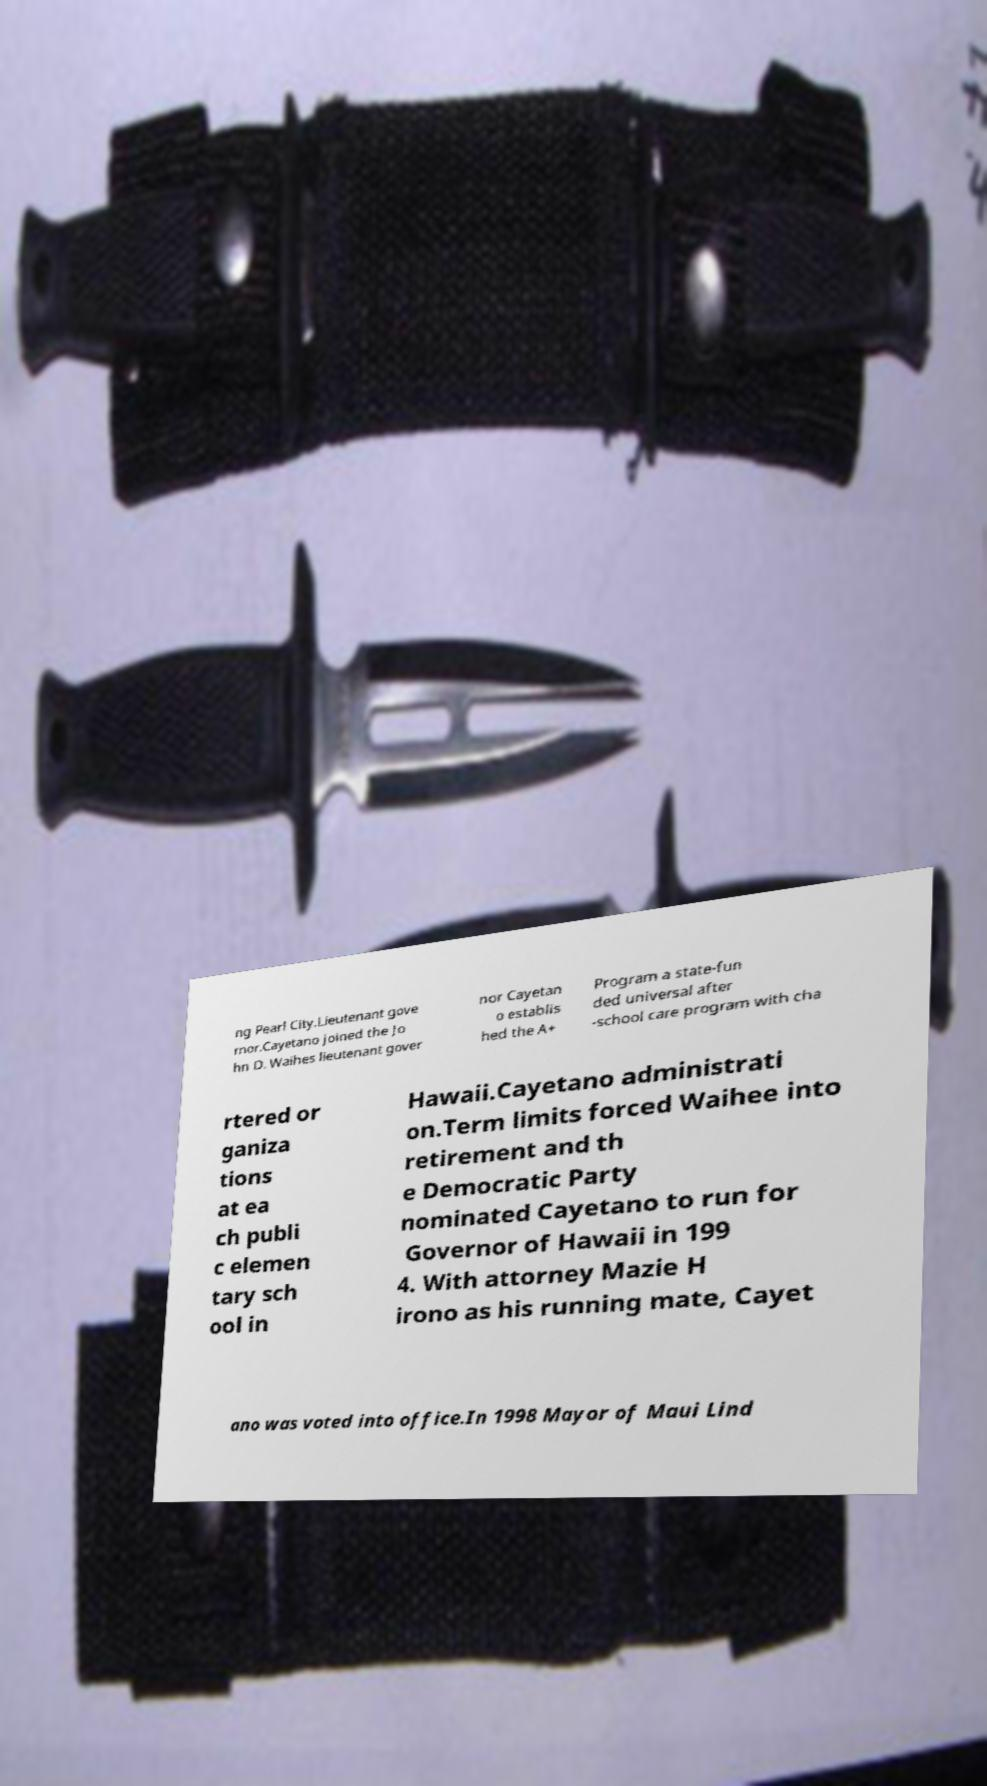I need the written content from this picture converted into text. Can you do that? ng Pearl City.Lieutenant gove rnor.Cayetano joined the Jo hn D. Waihes lieutenant gover nor Cayetan o establis hed the A+ Program a state-fun ded universal after -school care program with cha rtered or ganiza tions at ea ch publi c elemen tary sch ool in Hawaii.Cayetano administrati on.Term limits forced Waihee into retirement and th e Democratic Party nominated Cayetano to run for Governor of Hawaii in 199 4. With attorney Mazie H irono as his running mate, Cayet ano was voted into office.In 1998 Mayor of Maui Lind 